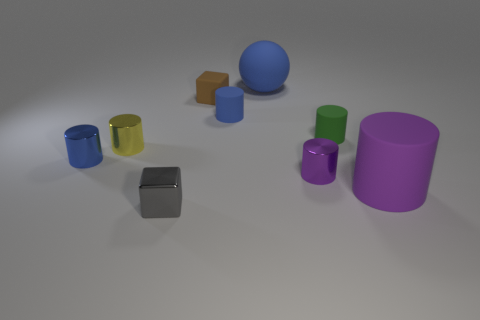Is there a small brown rubber cube that is on the right side of the small blue cylinder that is behind the tiny yellow cylinder?
Your answer should be compact. No. What is the color of the small thing that is both to the right of the matte cube and behind the small green matte object?
Keep it short and to the point. Blue. Is there a cube in front of the tiny matte cylinder that is to the right of the large matte thing that is to the left of the green matte cylinder?
Your answer should be very brief. Yes. The other object that is the same shape as the small gray object is what size?
Provide a succinct answer. Small. Is there anything else that has the same material as the small purple object?
Your answer should be very brief. Yes. Are any gray metal objects visible?
Offer a very short reply. Yes. Is the color of the ball the same as the big thing that is right of the blue ball?
Offer a terse response. No. What size is the rubber cylinder that is in front of the metallic cylinder that is in front of the object that is to the left of the tiny yellow cylinder?
Your response must be concise. Large. What number of objects have the same color as the large matte cylinder?
Your answer should be compact. 1. How many things are red blocks or cylinders left of the small metallic cube?
Offer a very short reply. 2. 